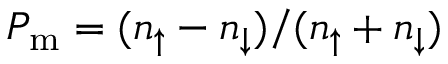Convert formula to latex. <formula><loc_0><loc_0><loc_500><loc_500>P _ { m } = ( n _ { \uparrow } - n _ { \downarrow } ) / ( n _ { \uparrow } + n _ { \downarrow } )</formula> 